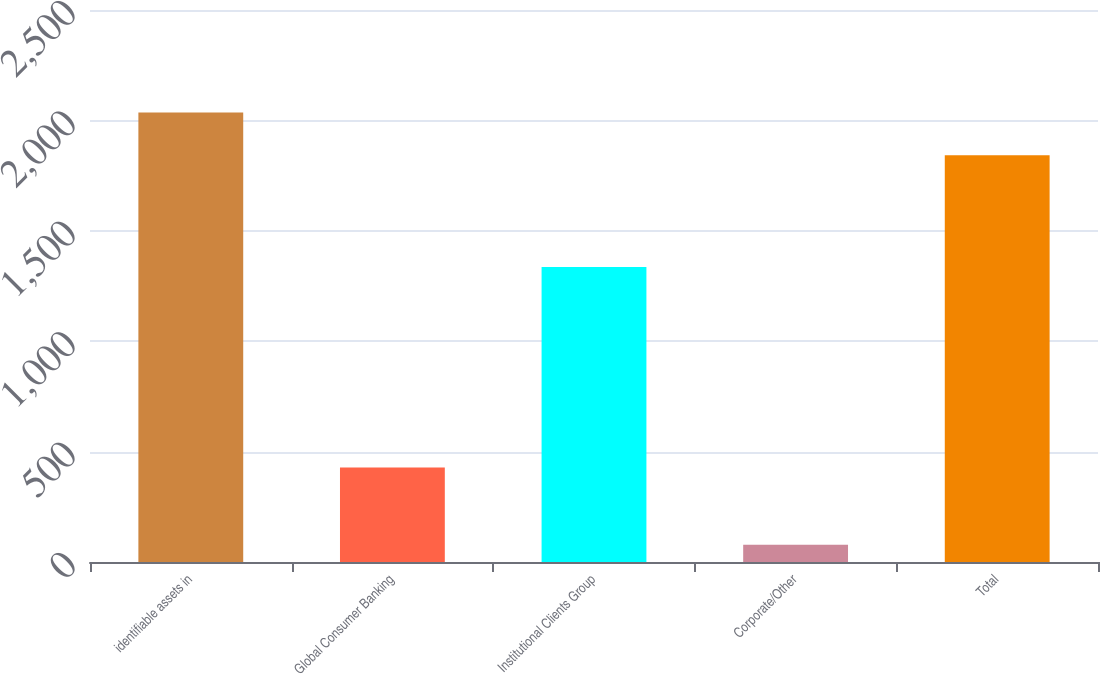Convert chart. <chart><loc_0><loc_0><loc_500><loc_500><bar_chart><fcel>identifiable assets in<fcel>Global Consumer Banking<fcel>Institutional Clients Group<fcel>Corporate/Other<fcel>Total<nl><fcel>2035.9<fcel>428<fcel>1336<fcel>78<fcel>1842<nl></chart> 